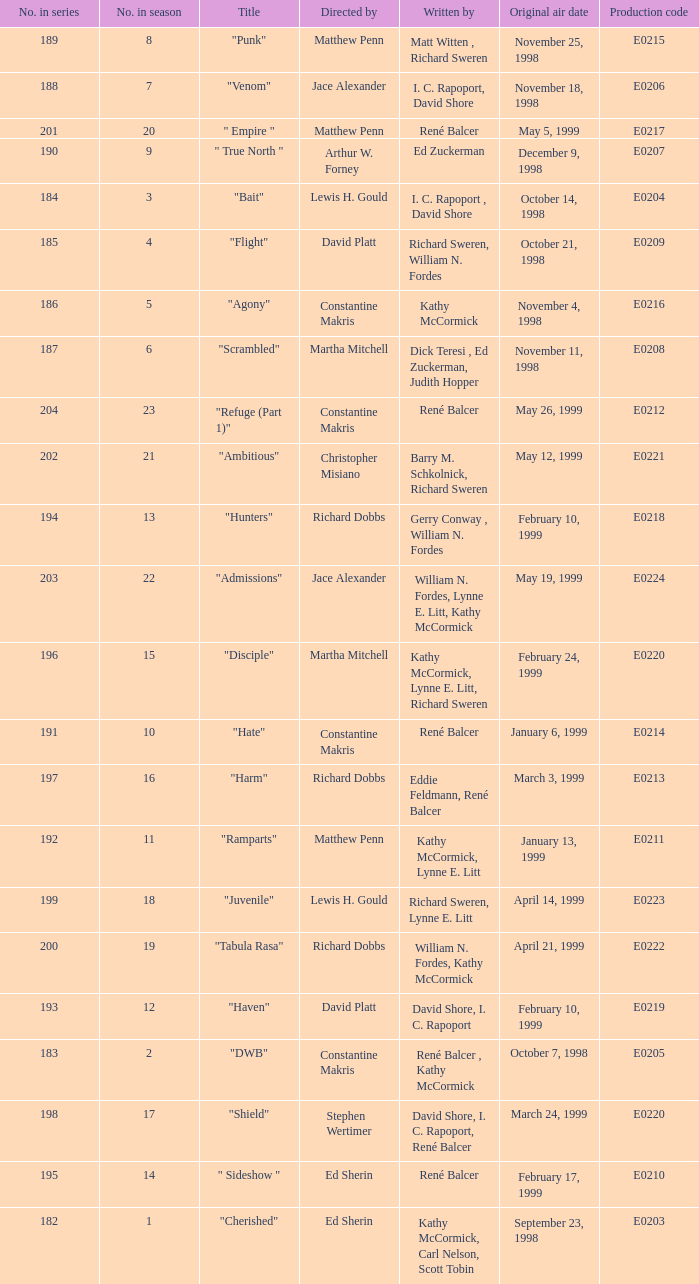The episode with the original air date January 6, 1999, has what production code? E0214. 